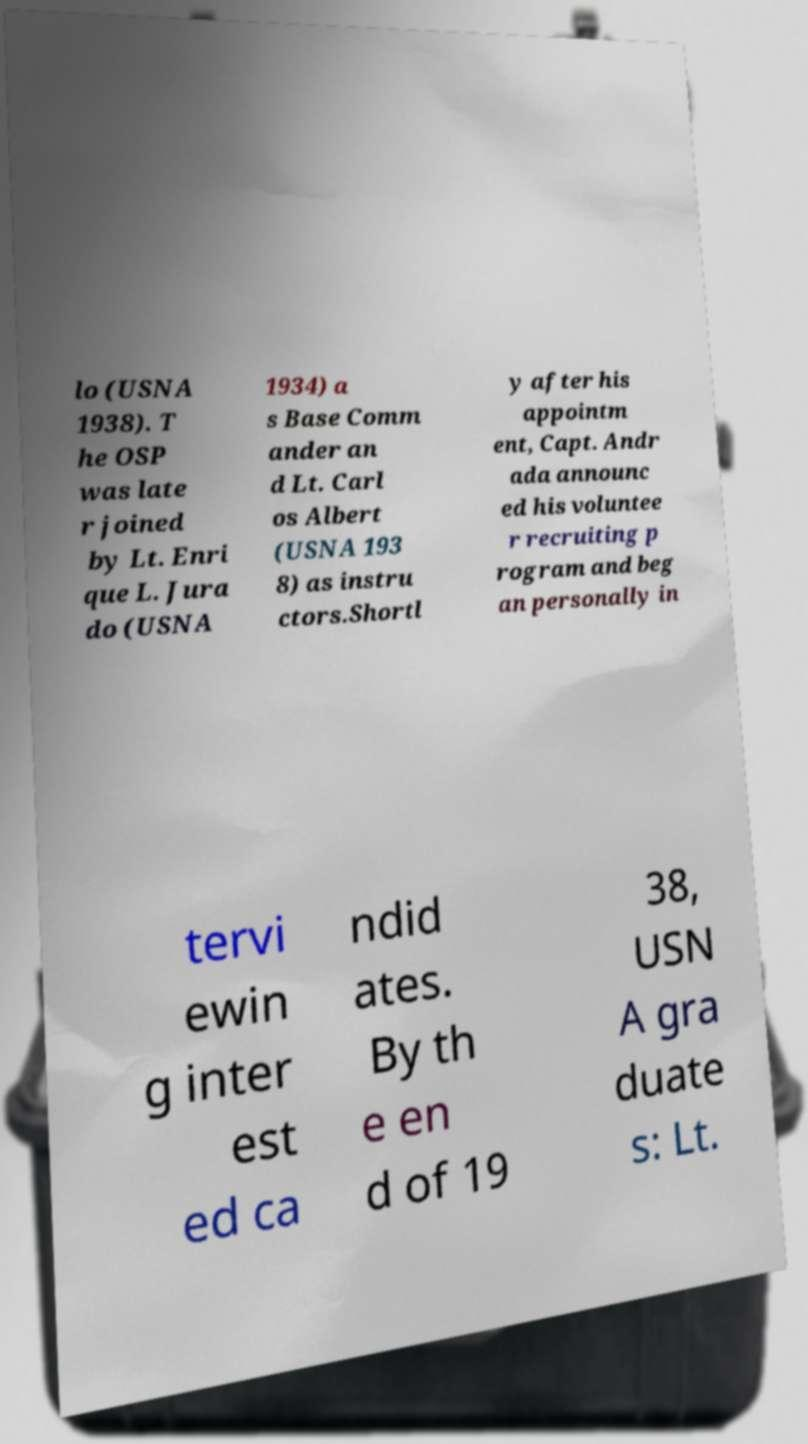There's text embedded in this image that I need extracted. Can you transcribe it verbatim? lo (USNA 1938). T he OSP was late r joined by Lt. Enri que L. Jura do (USNA 1934) a s Base Comm ander an d Lt. Carl os Albert (USNA 193 8) as instru ctors.Shortl y after his appointm ent, Capt. Andr ada announc ed his voluntee r recruiting p rogram and beg an personally in tervi ewin g inter est ed ca ndid ates. By th e en d of 19 38, USN A gra duate s: Lt. 